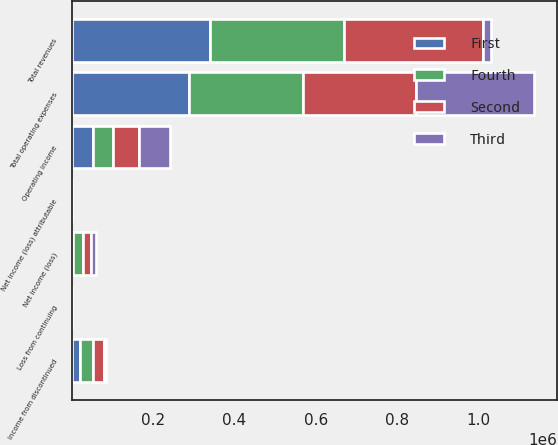Convert chart to OTSL. <chart><loc_0><loc_0><loc_500><loc_500><stacked_bar_chart><ecel><fcel>Total revenues<fcel>Total operating expenses<fcel>Operating income<fcel>Loss from continuing<fcel>Income from discontinued<fcel>Net income (loss)<fcel>Net income (loss) attributable<nl><fcel>Fourth<fcel>329154<fcel>281623<fcel>47531<fcel>0.17<fcel>32644<fcel>25208<fcel>0.06<nl><fcel>Second<fcel>340859<fcel>277212<fcel>63647<fcel>0.17<fcel>27328<fcel>19329<fcel>0.02<nl><fcel>First<fcel>340454<fcel>287305<fcel>53149<fcel>0.29<fcel>19324<fcel>2341<fcel>0.15<nl><fcel>Third<fcel>19329<fcel>288925<fcel>77428<fcel>0.22<fcel>3799<fcel>12285<fcel>0.19<nl></chart> 